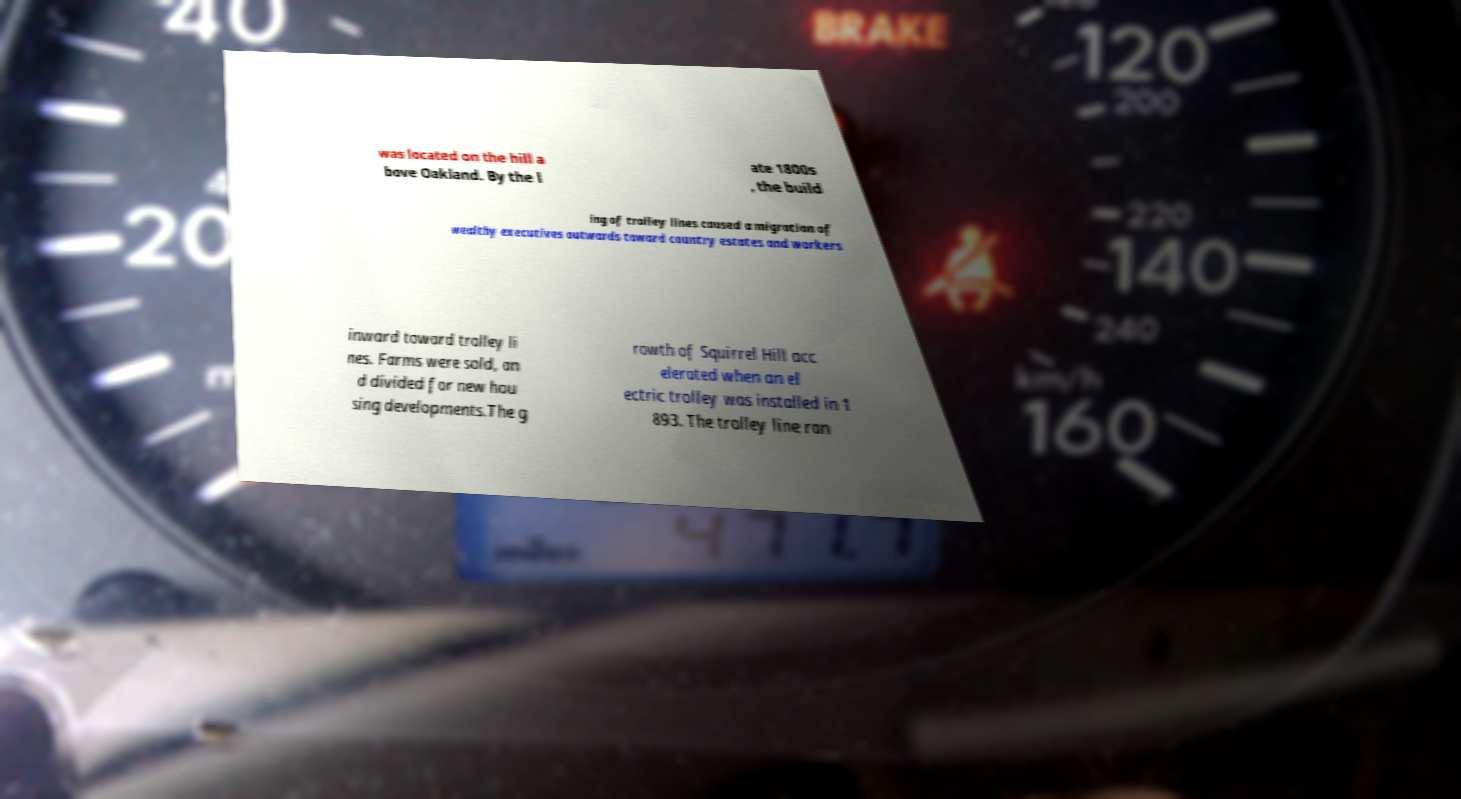What messages or text are displayed in this image? I need them in a readable, typed format. was located on the hill a bove Oakland. By the l ate 1800s , the build ing of trolley lines caused a migration of wealthy executives outwards toward country estates and workers inward toward trolley li nes. Farms were sold, an d divided for new hou sing developments.The g rowth of Squirrel Hill acc elerated when an el ectric trolley was installed in 1 893. The trolley line ran 